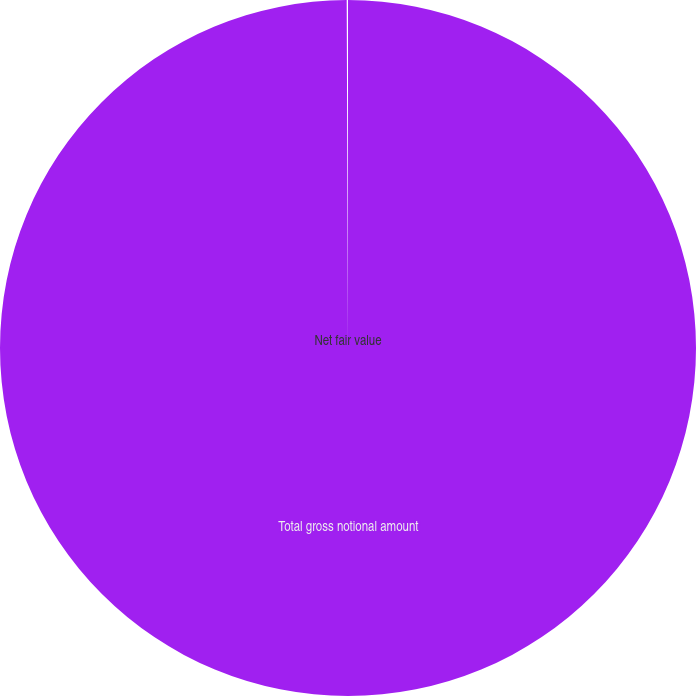Convert chart to OTSL. <chart><loc_0><loc_0><loc_500><loc_500><pie_chart><fcel>Total gross notional amount<fcel>Net fair value<nl><fcel>99.94%<fcel>0.06%<nl></chart> 